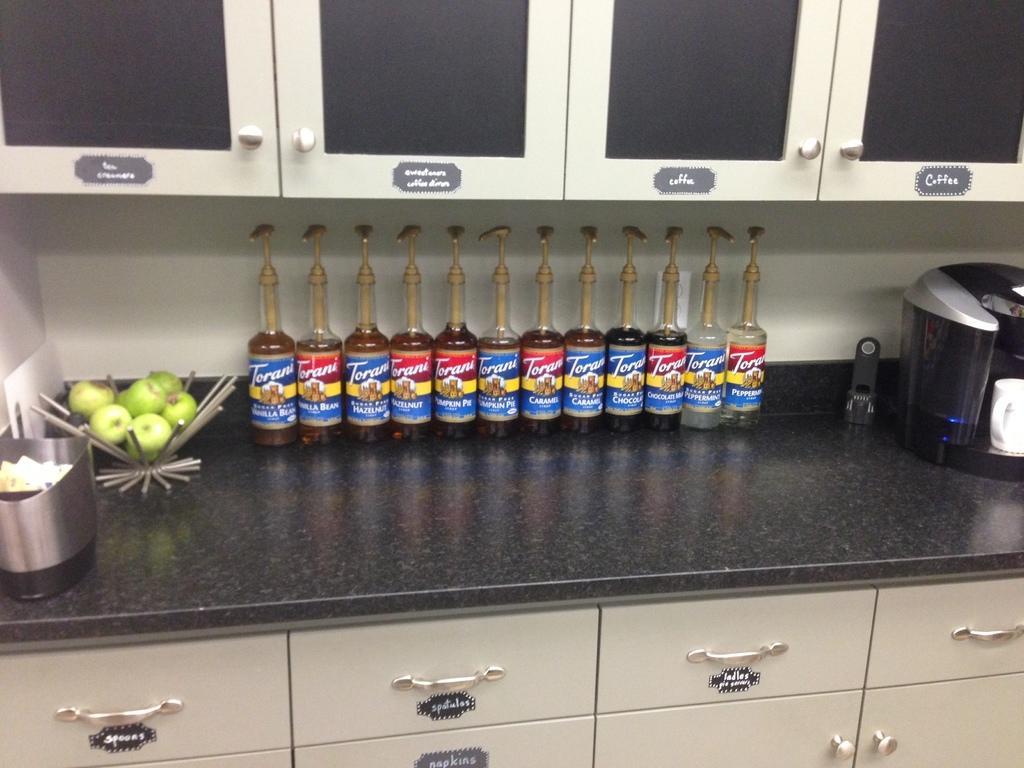Please provide a concise description of this image. In this image i can see the kitchen counter top on which there are few fruits and few bottles,a coffee maker and few other objects, i can see few cupboards and few drawers. 